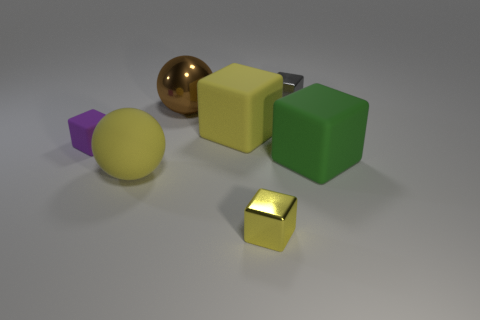There is a yellow object that is to the left of the brown object; what shape is it?
Provide a succinct answer. Sphere. What shape is the yellow thing that is made of the same material as the large yellow sphere?
Make the answer very short. Cube. What number of metallic objects are gray cubes or yellow objects?
Keep it short and to the point. 2. How many purple things are behind the rubber thing to the right of the small shiny thing behind the purple cube?
Offer a terse response. 1. Is the size of the block that is to the right of the gray metallic thing the same as the yellow block that is behind the large yellow sphere?
Your answer should be very brief. Yes. What is the material of the large yellow thing that is the same shape as the brown thing?
Your answer should be compact. Rubber. How many tiny objects are gray cylinders or brown balls?
Offer a terse response. 0. What is the tiny yellow thing made of?
Keep it short and to the point. Metal. There is a object that is behind the big green matte block and on the left side of the big metallic thing; what material is it made of?
Offer a terse response. Rubber. There is a matte sphere; is it the same color as the small thing in front of the matte sphere?
Give a very brief answer. Yes. 